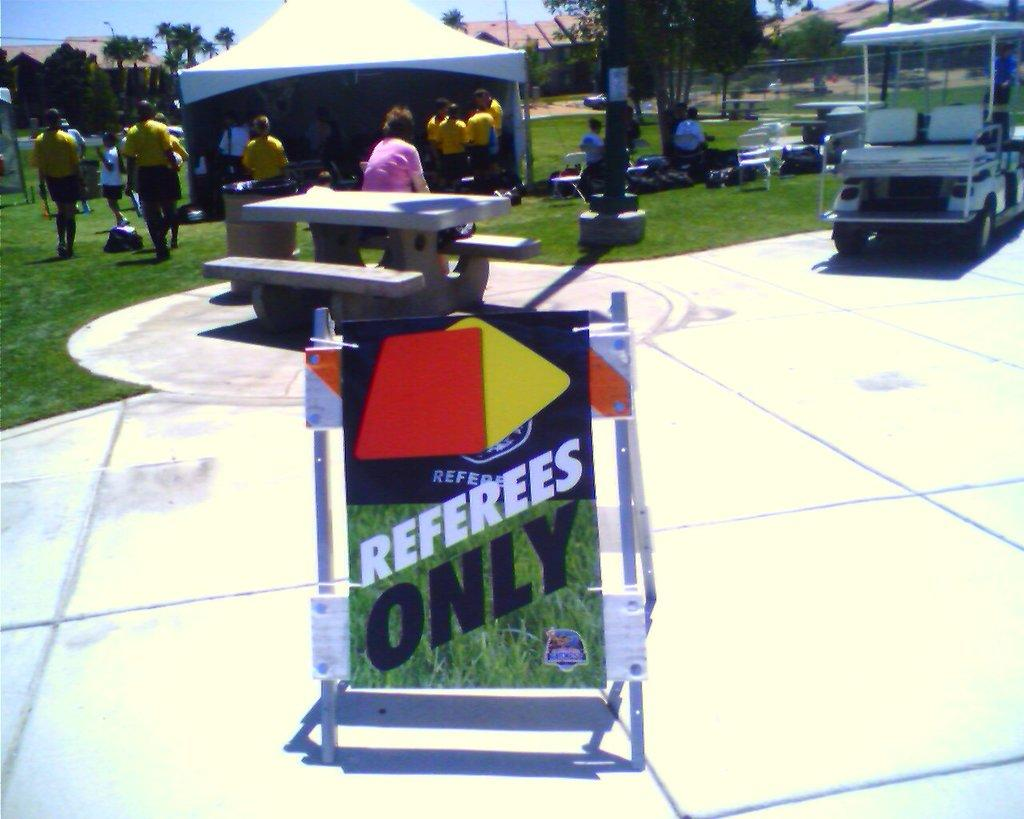<image>
Write a terse but informative summary of the picture. Sign on the ground which says Referees only. 